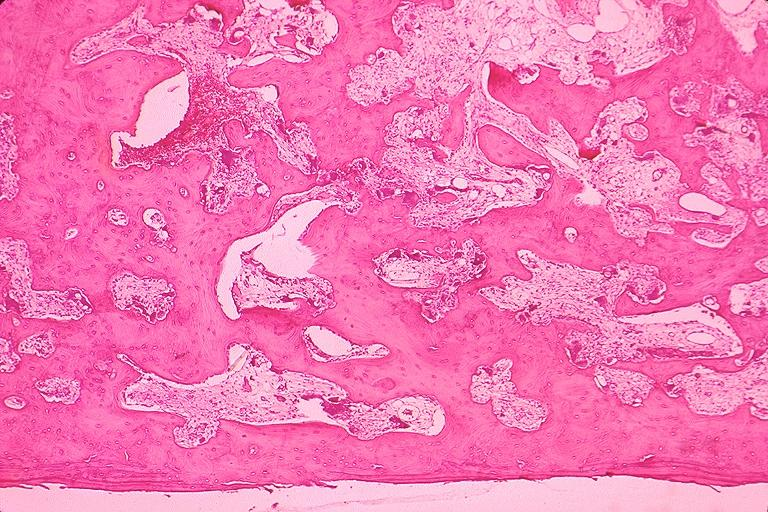does this image show pagets disease?
Answer the question using a single word or phrase. Yes 